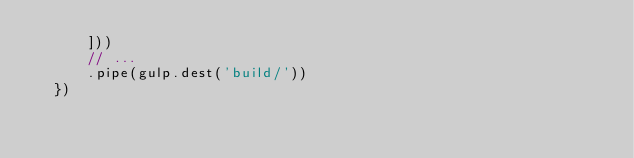<code> <loc_0><loc_0><loc_500><loc_500><_JavaScript_>      ]))
      // ...
      .pipe(gulp.dest('build/'))
  })
</code> 